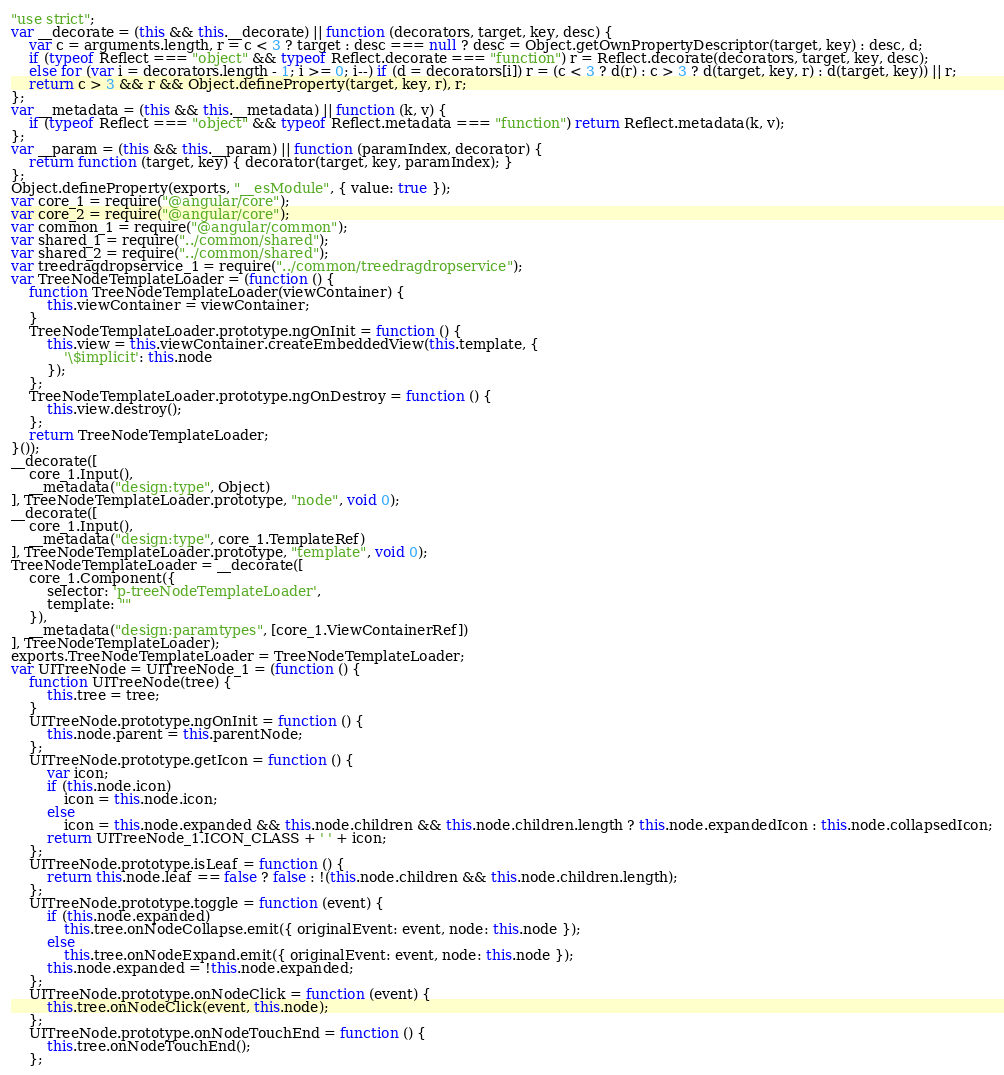Convert code to text. <code><loc_0><loc_0><loc_500><loc_500><_JavaScript_>"use strict";
var __decorate = (this && this.__decorate) || function (decorators, target, key, desc) {
    var c = arguments.length, r = c < 3 ? target : desc === null ? desc = Object.getOwnPropertyDescriptor(target, key) : desc, d;
    if (typeof Reflect === "object" && typeof Reflect.decorate === "function") r = Reflect.decorate(decorators, target, key, desc);
    else for (var i = decorators.length - 1; i >= 0; i--) if (d = decorators[i]) r = (c < 3 ? d(r) : c > 3 ? d(target, key, r) : d(target, key)) || r;
    return c > 3 && r && Object.defineProperty(target, key, r), r;
};
var __metadata = (this && this.__metadata) || function (k, v) {
    if (typeof Reflect === "object" && typeof Reflect.metadata === "function") return Reflect.metadata(k, v);
};
var __param = (this && this.__param) || function (paramIndex, decorator) {
    return function (target, key) { decorator(target, key, paramIndex); }
};
Object.defineProperty(exports, "__esModule", { value: true });
var core_1 = require("@angular/core");
var core_2 = require("@angular/core");
var common_1 = require("@angular/common");
var shared_1 = require("../common/shared");
var shared_2 = require("../common/shared");
var treedragdropservice_1 = require("../common/treedragdropservice");
var TreeNodeTemplateLoader = (function () {
    function TreeNodeTemplateLoader(viewContainer) {
        this.viewContainer = viewContainer;
    }
    TreeNodeTemplateLoader.prototype.ngOnInit = function () {
        this.view = this.viewContainer.createEmbeddedView(this.template, {
            '\$implicit': this.node
        });
    };
    TreeNodeTemplateLoader.prototype.ngOnDestroy = function () {
        this.view.destroy();
    };
    return TreeNodeTemplateLoader;
}());
__decorate([
    core_1.Input(),
    __metadata("design:type", Object)
], TreeNodeTemplateLoader.prototype, "node", void 0);
__decorate([
    core_1.Input(),
    __metadata("design:type", core_1.TemplateRef)
], TreeNodeTemplateLoader.prototype, "template", void 0);
TreeNodeTemplateLoader = __decorate([
    core_1.Component({
        selector: 'p-treeNodeTemplateLoader',
        template: ""
    }),
    __metadata("design:paramtypes", [core_1.ViewContainerRef])
], TreeNodeTemplateLoader);
exports.TreeNodeTemplateLoader = TreeNodeTemplateLoader;
var UITreeNode = UITreeNode_1 = (function () {
    function UITreeNode(tree) {
        this.tree = tree;
    }
    UITreeNode.prototype.ngOnInit = function () {
        this.node.parent = this.parentNode;
    };
    UITreeNode.prototype.getIcon = function () {
        var icon;
        if (this.node.icon)
            icon = this.node.icon;
        else
            icon = this.node.expanded && this.node.children && this.node.children.length ? this.node.expandedIcon : this.node.collapsedIcon;
        return UITreeNode_1.ICON_CLASS + ' ' + icon;
    };
    UITreeNode.prototype.isLeaf = function () {
        return this.node.leaf == false ? false : !(this.node.children && this.node.children.length);
    };
    UITreeNode.prototype.toggle = function (event) {
        if (this.node.expanded)
            this.tree.onNodeCollapse.emit({ originalEvent: event, node: this.node });
        else
            this.tree.onNodeExpand.emit({ originalEvent: event, node: this.node });
        this.node.expanded = !this.node.expanded;
    };
    UITreeNode.prototype.onNodeClick = function (event) {
        this.tree.onNodeClick(event, this.node);
    };
    UITreeNode.prototype.onNodeTouchEnd = function () {
        this.tree.onNodeTouchEnd();
    };</code> 